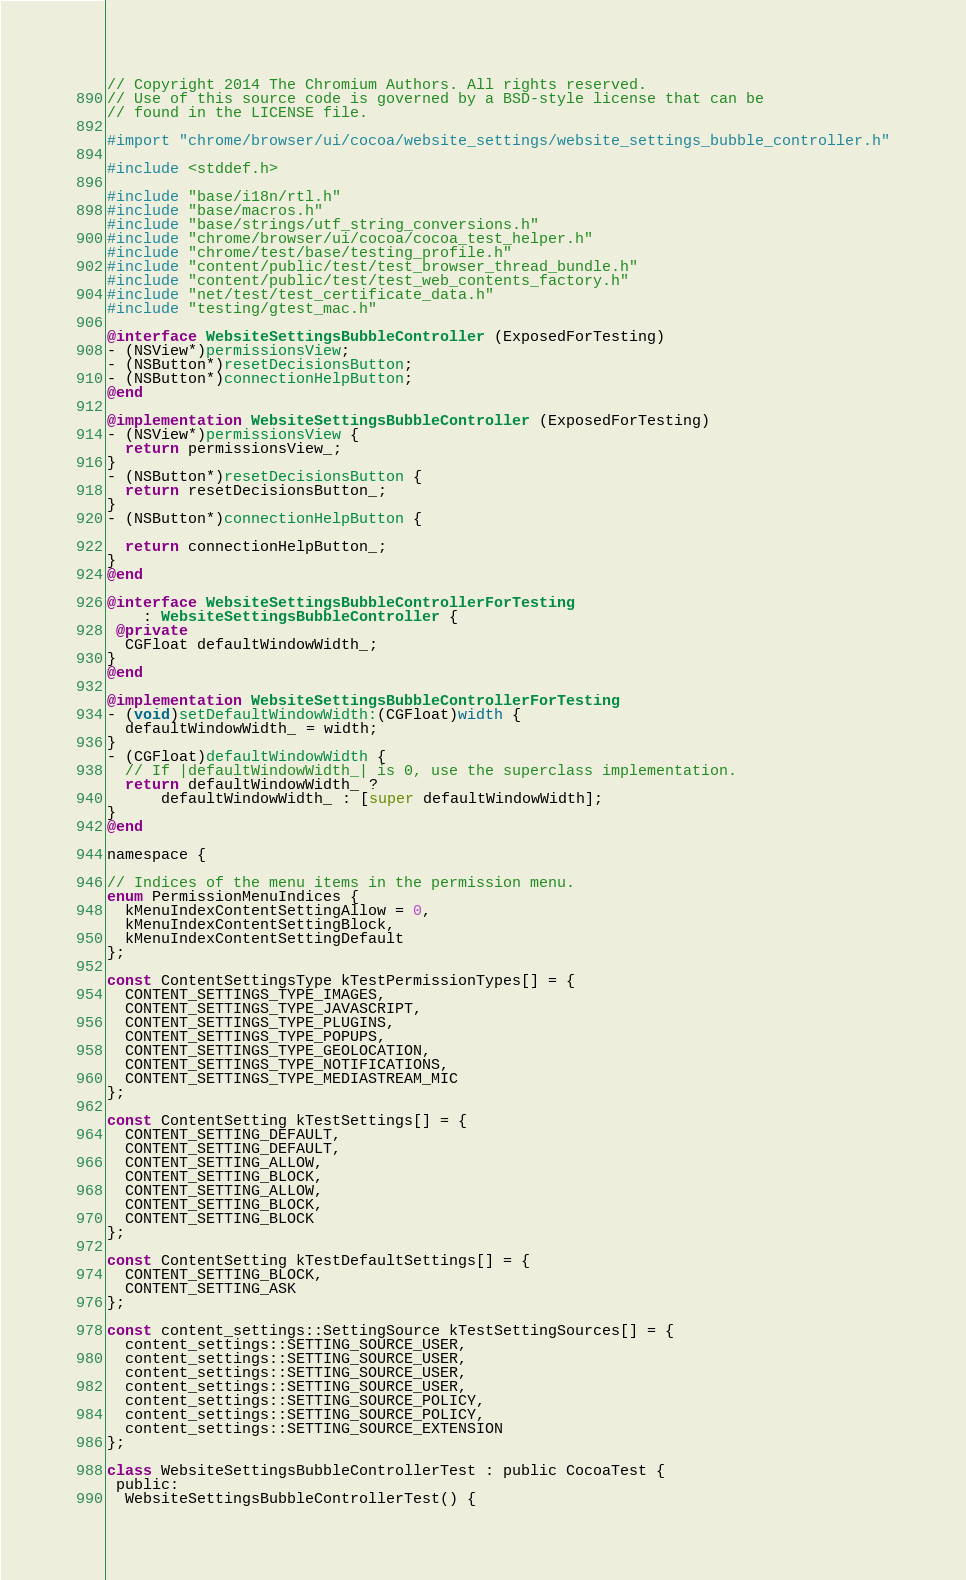<code> <loc_0><loc_0><loc_500><loc_500><_ObjectiveC_>// Copyright 2014 The Chromium Authors. All rights reserved.
// Use of this source code is governed by a BSD-style license that can be
// found in the LICENSE file.

#import "chrome/browser/ui/cocoa/website_settings/website_settings_bubble_controller.h"

#include <stddef.h>

#include "base/i18n/rtl.h"
#include "base/macros.h"
#include "base/strings/utf_string_conversions.h"
#include "chrome/browser/ui/cocoa/cocoa_test_helper.h"
#include "chrome/test/base/testing_profile.h"
#include "content/public/test/test_browser_thread_bundle.h"
#include "content/public/test/test_web_contents_factory.h"
#include "net/test/test_certificate_data.h"
#include "testing/gtest_mac.h"

@interface WebsiteSettingsBubbleController (ExposedForTesting)
- (NSView*)permissionsView;
- (NSButton*)resetDecisionsButton;
- (NSButton*)connectionHelpButton;
@end

@implementation WebsiteSettingsBubbleController (ExposedForTesting)
- (NSView*)permissionsView {
  return permissionsView_;
}
- (NSButton*)resetDecisionsButton {
  return resetDecisionsButton_;
}
- (NSButton*)connectionHelpButton {

  return connectionHelpButton_;
}
@end

@interface WebsiteSettingsBubbleControllerForTesting
    : WebsiteSettingsBubbleController {
 @private
  CGFloat defaultWindowWidth_;
}
@end

@implementation WebsiteSettingsBubbleControllerForTesting
- (void)setDefaultWindowWidth:(CGFloat)width {
  defaultWindowWidth_ = width;
}
- (CGFloat)defaultWindowWidth {
  // If |defaultWindowWidth_| is 0, use the superclass implementation.
  return defaultWindowWidth_ ?
      defaultWindowWidth_ : [super defaultWindowWidth];
}
@end

namespace {

// Indices of the menu items in the permission menu.
enum PermissionMenuIndices {
  kMenuIndexContentSettingAllow = 0,
  kMenuIndexContentSettingBlock,
  kMenuIndexContentSettingDefault
};

const ContentSettingsType kTestPermissionTypes[] = {
  CONTENT_SETTINGS_TYPE_IMAGES,
  CONTENT_SETTINGS_TYPE_JAVASCRIPT,
  CONTENT_SETTINGS_TYPE_PLUGINS,
  CONTENT_SETTINGS_TYPE_POPUPS,
  CONTENT_SETTINGS_TYPE_GEOLOCATION,
  CONTENT_SETTINGS_TYPE_NOTIFICATIONS,
  CONTENT_SETTINGS_TYPE_MEDIASTREAM_MIC
};

const ContentSetting kTestSettings[] = {
  CONTENT_SETTING_DEFAULT,
  CONTENT_SETTING_DEFAULT,
  CONTENT_SETTING_ALLOW,
  CONTENT_SETTING_BLOCK,
  CONTENT_SETTING_ALLOW,
  CONTENT_SETTING_BLOCK,
  CONTENT_SETTING_BLOCK
};

const ContentSetting kTestDefaultSettings[] = {
  CONTENT_SETTING_BLOCK,
  CONTENT_SETTING_ASK
};

const content_settings::SettingSource kTestSettingSources[] = {
  content_settings::SETTING_SOURCE_USER,
  content_settings::SETTING_SOURCE_USER,
  content_settings::SETTING_SOURCE_USER,
  content_settings::SETTING_SOURCE_USER,
  content_settings::SETTING_SOURCE_POLICY,
  content_settings::SETTING_SOURCE_POLICY,
  content_settings::SETTING_SOURCE_EXTENSION
};

class WebsiteSettingsBubbleControllerTest : public CocoaTest {
 public:
  WebsiteSettingsBubbleControllerTest() {</code> 